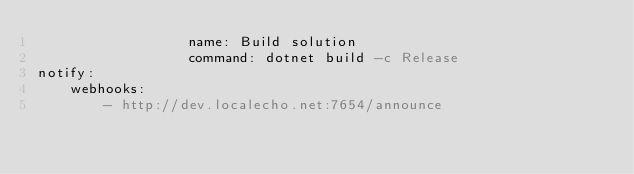<code> <loc_0><loc_0><loc_500><loc_500><_YAML_>                  name: Build solution
                  command: dotnet build -c Release
notify:
    webhooks:
        - http://dev.localecho.net:7654/announce</code> 